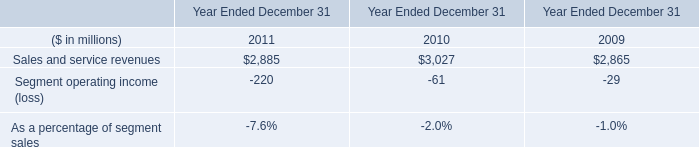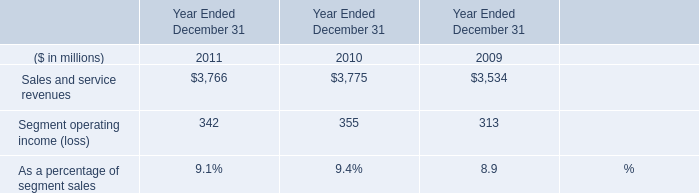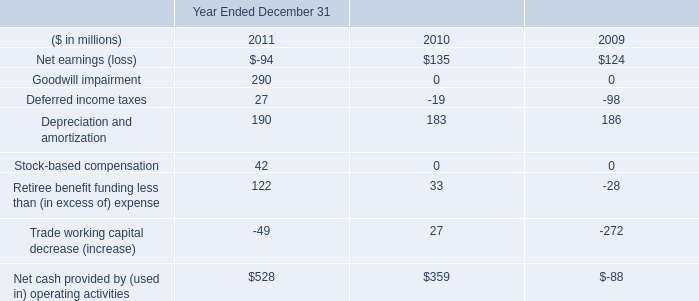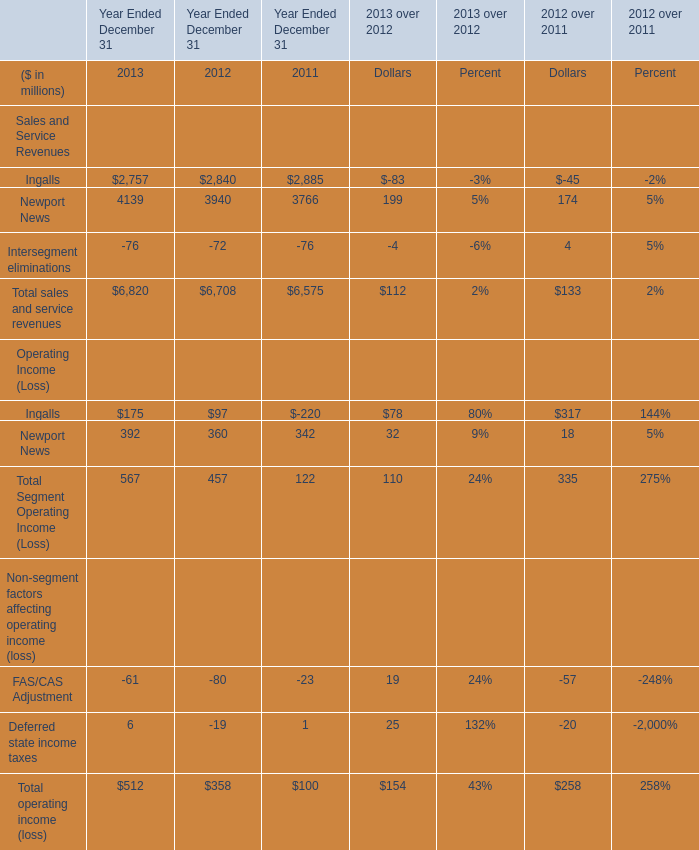What is the average value of Total sales and service revenues in Table 3 and Segment operating income (loss) in Table 0 in 2011? (in million) 
Computations: ((6575 - 220) / 2)
Answer: 3177.5. 